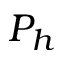Convert formula to latex. <formula><loc_0><loc_0><loc_500><loc_500>P _ { h }</formula> 